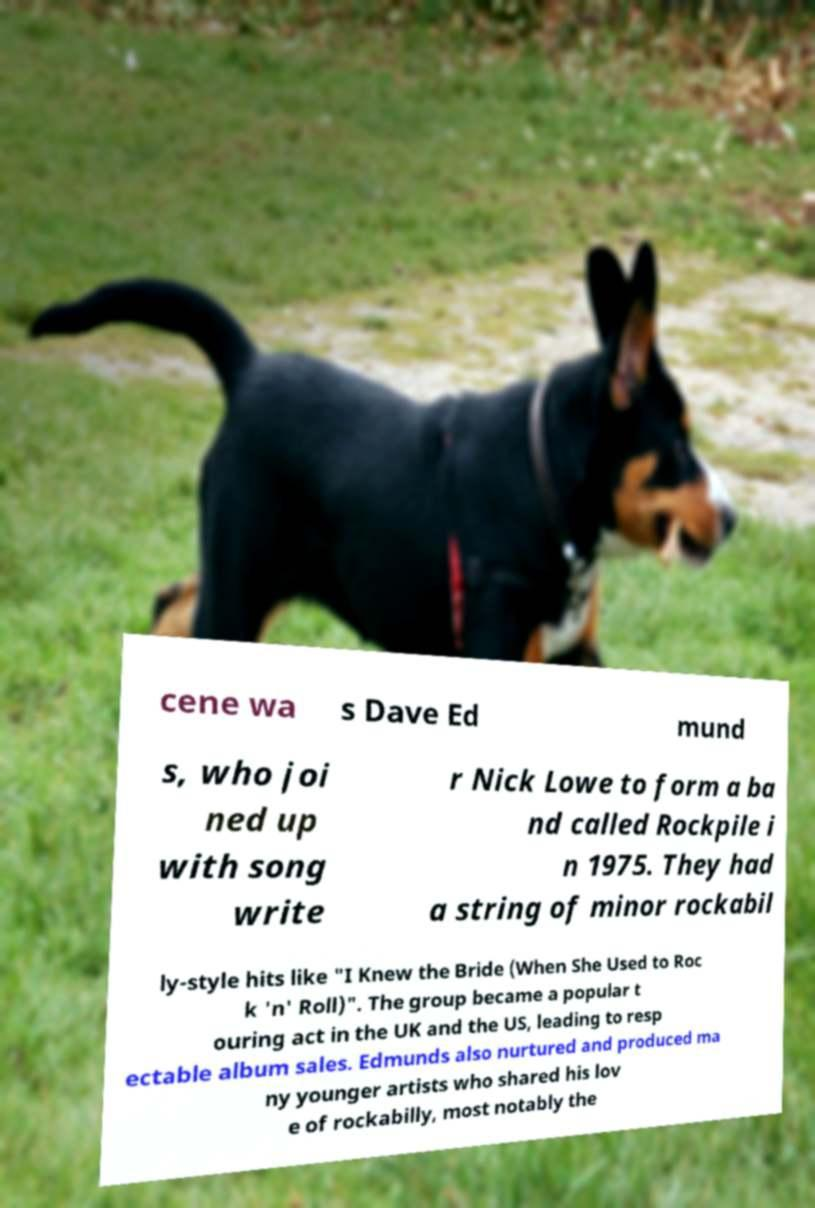What messages or text are displayed in this image? I need them in a readable, typed format. cene wa s Dave Ed mund s, who joi ned up with song write r Nick Lowe to form a ba nd called Rockpile i n 1975. They had a string of minor rockabil ly-style hits like "I Knew the Bride (When She Used to Roc k 'n' Roll)". The group became a popular t ouring act in the UK and the US, leading to resp ectable album sales. Edmunds also nurtured and produced ma ny younger artists who shared his lov e of rockabilly, most notably the 